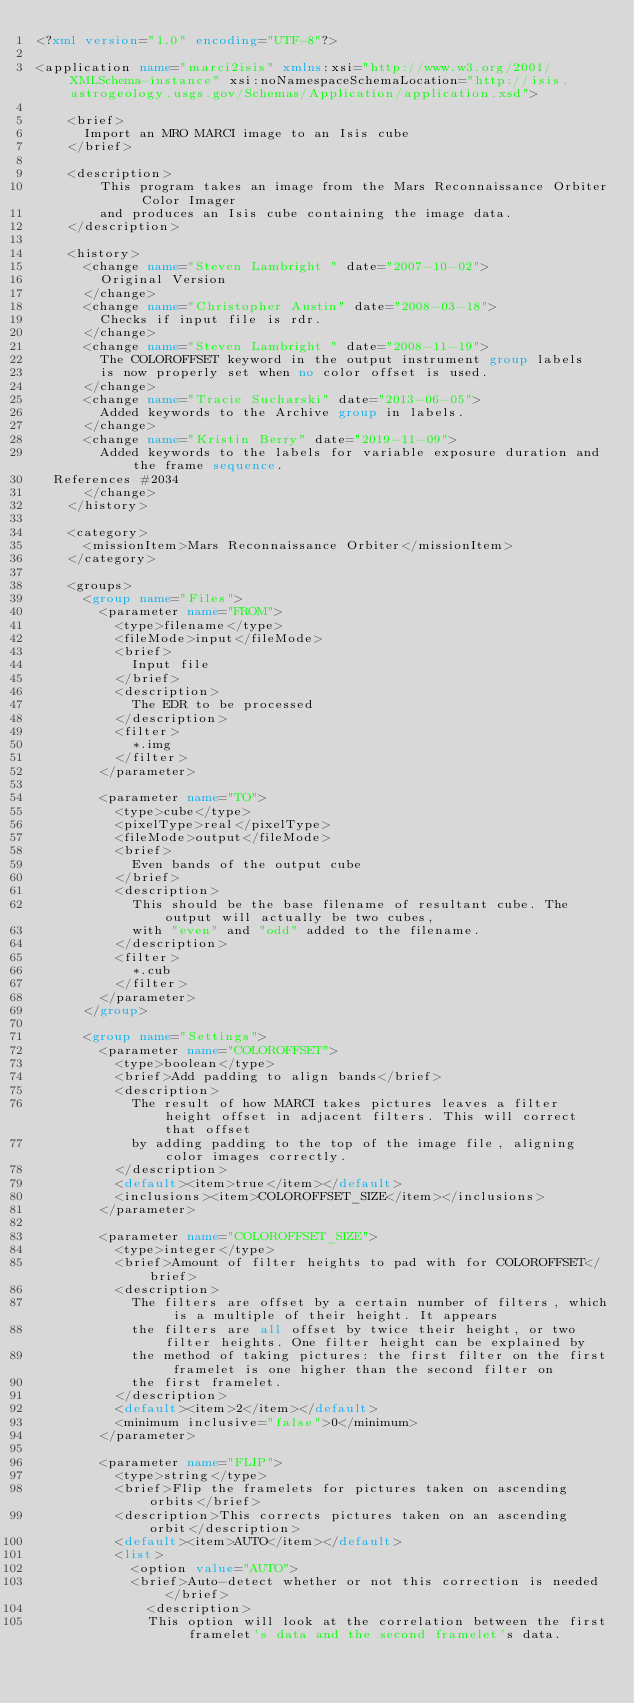Convert code to text. <code><loc_0><loc_0><loc_500><loc_500><_XML_><?xml version="1.0" encoding="UTF-8"?>

<application name="marci2isis" xmlns:xsi="http://www.w3.org/2001/XMLSchema-instance" xsi:noNamespaceSchemaLocation="http://isis.astrogeology.usgs.gov/Schemas/Application/application.xsd">

    <brief>
      Import an MRO MARCI image to an Isis cube
    </brief>

    <description>
        This program takes an image from the Mars Reconnaissance Orbiter Color Imager
        and produces an Isis cube containing the image data.
    </description>

    <history>
      <change name="Steven Lambright " date="2007-10-02">
        Original Version
      </change>
      <change name="Christopher Austin" date="2008-03-18">
        Checks if input file is rdr.
      </change>
      <change name="Steven Lambright " date="2008-11-19">
        The COLOROFFSET keyword in the output instrument group labels
        is now properly set when no color offset is used.
      </change>
      <change name="Tracie Sucharski" date="2013-06-05">
        Added keywords to the Archive group in labels.
      </change>
      <change name="Kristin Berry" date="2019-11-09">
        Added keywords to the labels for variable exposure duration and the frame sequence. 
	References #2034
      </change>
    </history>

    <category>
      <missionItem>Mars Reconnaissance Orbiter</missionItem>
    </category>

    <groups>
      <group name="Files">
        <parameter name="FROM">
          <type>filename</type>
          <fileMode>input</fileMode>
          <brief>
            Input file
          </brief>
          <description>
            The EDR to be processed
          </description>
          <filter>
            *.img
          </filter>
        </parameter>

        <parameter name="TO">
          <type>cube</type>
          <pixelType>real</pixelType>
          <fileMode>output</fileMode>
          <brief>
            Even bands of the output cube
          </brief>
          <description>
            This should be the base filename of resultant cube. The output will actually be two cubes,
            with "even" and "odd" added to the filename.
          </description>
          <filter>
            *.cub
          </filter>
        </parameter>
      </group>

      <group name="Settings">
        <parameter name="COLOROFFSET">
          <type>boolean</type>
          <brief>Add padding to align bands</brief>
          <description>
            The result of how MARCI takes pictures leaves a filter height offset in adjacent filters. This will correct that offset
            by adding padding to the top of the image file, aligning color images correctly.
          </description>
          <default><item>true</item></default>
          <inclusions><item>COLOROFFSET_SIZE</item></inclusions>
        </parameter>
           
        <parameter name="COLOROFFSET_SIZE">
          <type>integer</type>
          <brief>Amount of filter heights to pad with for COLOROFFSET</brief>
          <description>
            The filters are offset by a certain number of filters, which is a multiple of their height. It appears
            the filters are all offset by twice their height, or two filter heights. One filter height can be explained by
            the method of taking pictures: the first filter on the first framelet is one higher than the second filter on
            the first framelet.  
          </description>
          <default><item>2</item></default>
          <minimum inclusive="false">0</minimum>
        </parameter>
           
        <parameter name="FLIP">
          <type>string</type>
          <brief>Flip the framelets for pictures taken on ascending orbits</brief>
          <description>This corrects pictures taken on an ascending orbit</description>
          <default><item>AUTO</item></default>
          <list>
            <option value="AUTO">
            <brief>Auto-detect whether or not this correction is needed</brief>
              <description>
              This option will look at the correlation between the first framelet's data and the second framelet's data. </code> 